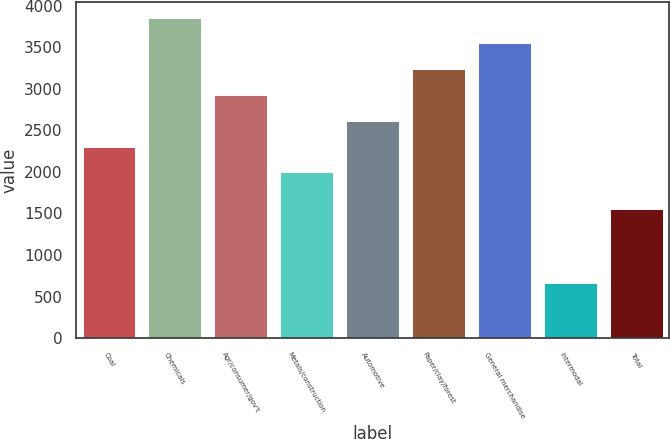Convert chart. <chart><loc_0><loc_0><loc_500><loc_500><bar_chart><fcel>Coal<fcel>Chemicals<fcel>Agr/consumer/gov't<fcel>Metals/construction<fcel>Automotive<fcel>Paper/clay/forest<fcel>General merchandise<fcel>Intermodal<fcel>Total<nl><fcel>2303.5<fcel>3856<fcel>2924.5<fcel>1993<fcel>2614<fcel>3235<fcel>3545.5<fcel>667<fcel>1553<nl></chart> 